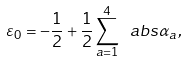Convert formula to latex. <formula><loc_0><loc_0><loc_500><loc_500>\varepsilon _ { 0 } = - \frac { 1 } { 2 } + \frac { 1 } { 2 } \sum _ { a = 1 } ^ { 4 } \ a b s { \alpha _ { a } } ,</formula> 